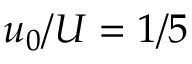Convert formula to latex. <formula><loc_0><loc_0><loc_500><loc_500>u _ { 0 } / U = 1 / 5</formula> 